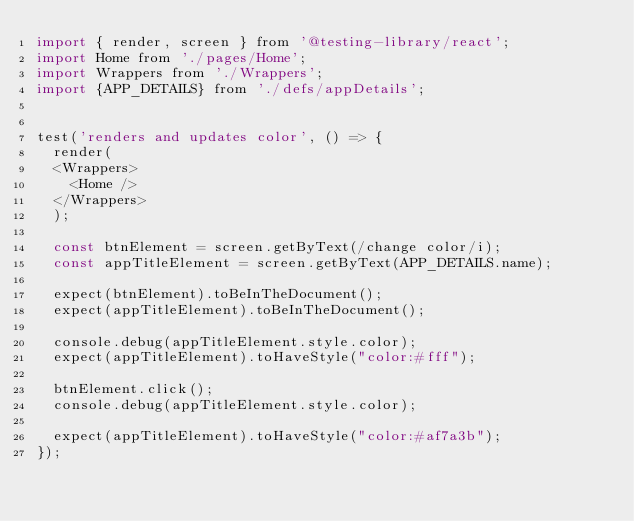<code> <loc_0><loc_0><loc_500><loc_500><_JavaScript_>import { render, screen } from '@testing-library/react';
import Home from './pages/Home';
import Wrappers from './Wrappers';
import {APP_DETAILS} from './defs/appDetails';


test('renders and updates color', () => {
  render(
  <Wrappers>
    <Home />
  </Wrappers>
  );

  const btnElement = screen.getByText(/change color/i);
  const appTitleElement = screen.getByText(APP_DETAILS.name);
  
  expect(btnElement).toBeInTheDocument();
  expect(appTitleElement).toBeInTheDocument();
  
  console.debug(appTitleElement.style.color);
  expect(appTitleElement).toHaveStyle("color:#fff");

  btnElement.click();
  console.debug(appTitleElement.style.color);

  expect(appTitleElement).toHaveStyle("color:#af7a3b");
});
</code> 